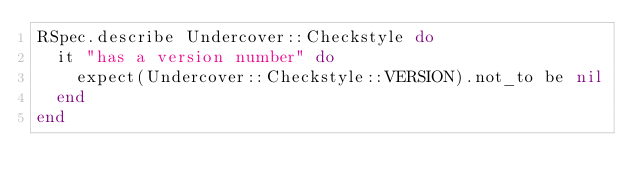Convert code to text. <code><loc_0><loc_0><loc_500><loc_500><_Ruby_>RSpec.describe Undercover::Checkstyle do
  it "has a version number" do
    expect(Undercover::Checkstyle::VERSION).not_to be nil
  end
end
</code> 